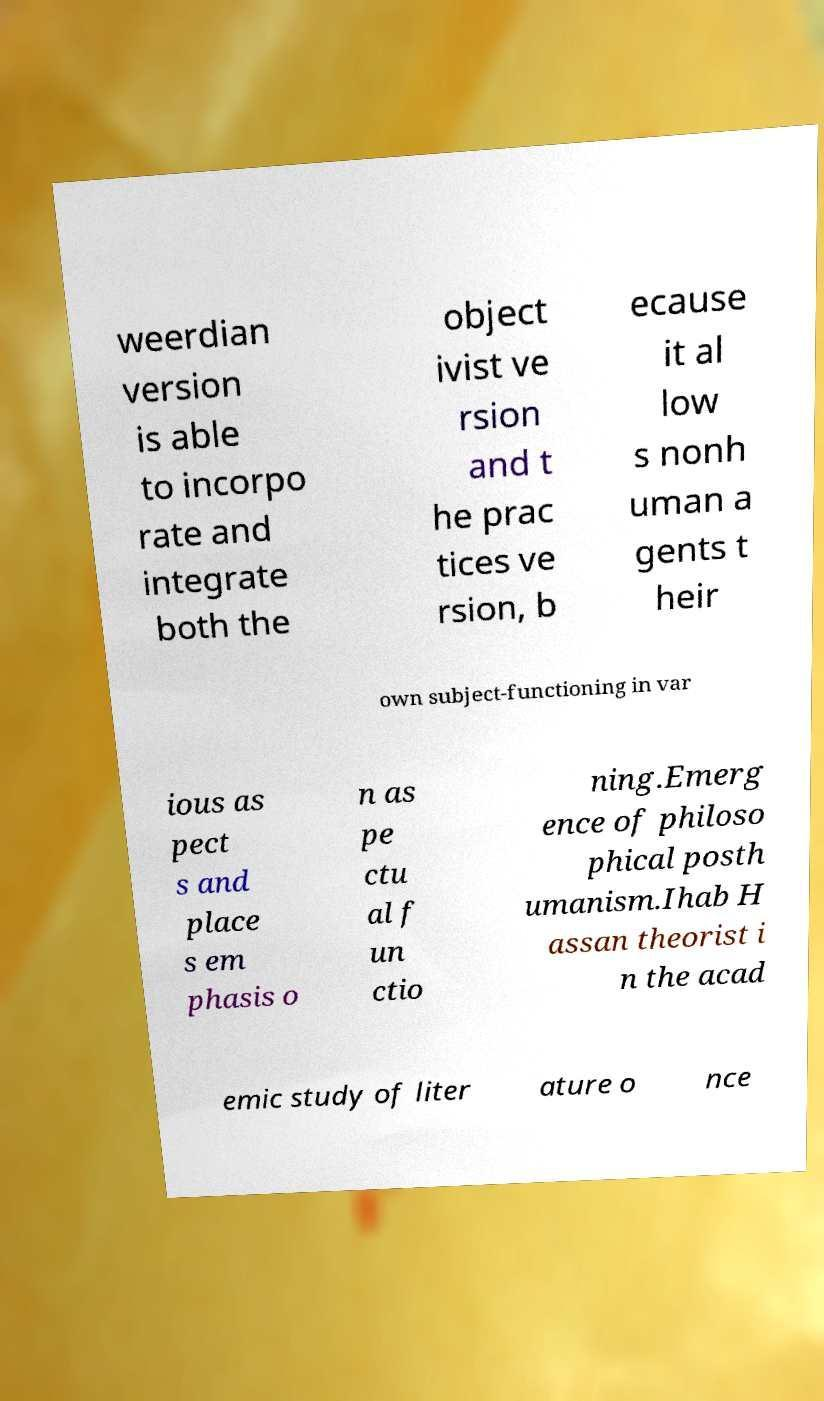Please identify and transcribe the text found in this image. weerdian version is able to incorpo rate and integrate both the object ivist ve rsion and t he prac tices ve rsion, b ecause it al low s nonh uman a gents t heir own subject-functioning in var ious as pect s and place s em phasis o n as pe ctu al f un ctio ning.Emerg ence of philoso phical posth umanism.Ihab H assan theorist i n the acad emic study of liter ature o nce 